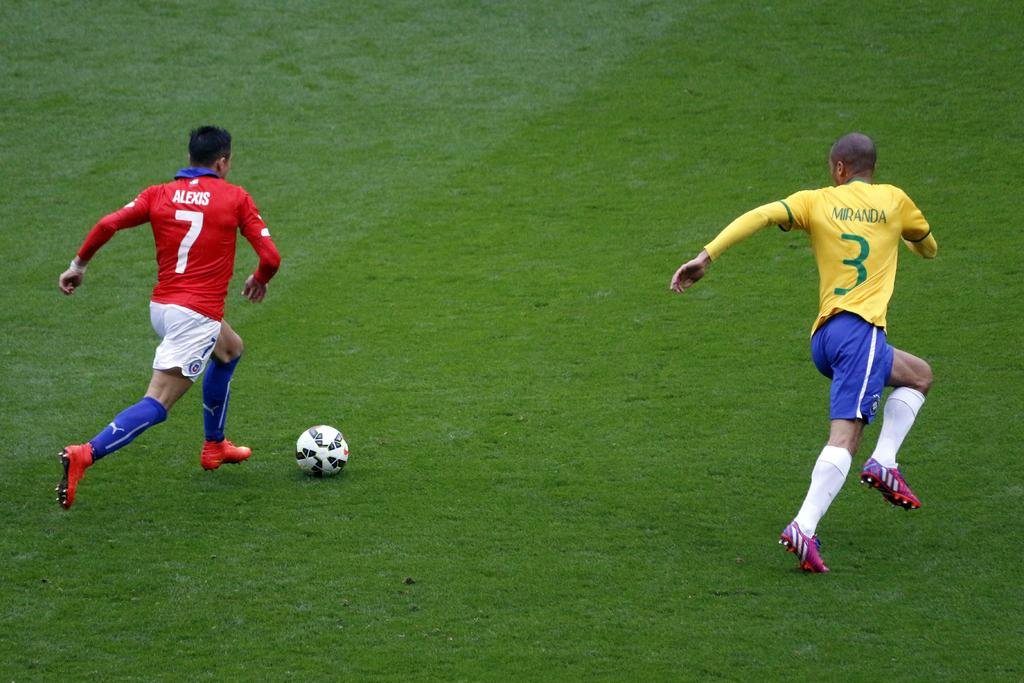<image>
Provide a brief description of the given image. Soccer player number 7 is moving the ball down the field while number 3 tries to stop him 